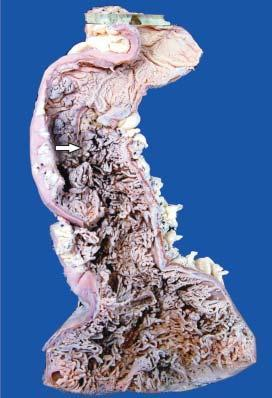s the mucosal surface straddled with multiple polyoid structures of varying sizes many of which are pedunculated?
Answer the question using a single word or phrase. Yes 